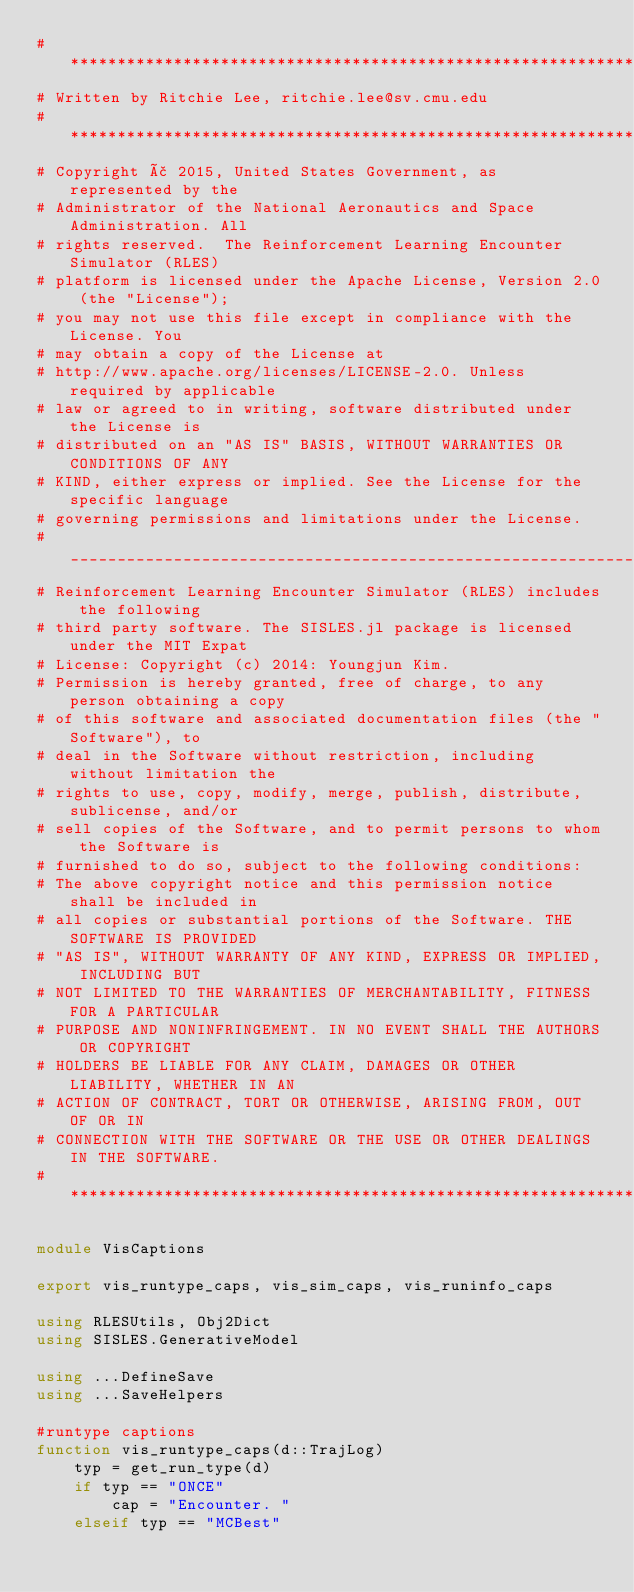Convert code to text. <code><loc_0><loc_0><loc_500><loc_500><_Julia_># *****************************************************************************
# Written by Ritchie Lee, ritchie.lee@sv.cmu.edu
# *****************************************************************************
# Copyright ã 2015, United States Government, as represented by the
# Administrator of the National Aeronautics and Space Administration. All
# rights reserved.  The Reinforcement Learning Encounter Simulator (RLES)
# platform is licensed under the Apache License, Version 2.0 (the "License");
# you may not use this file except in compliance with the License. You
# may obtain a copy of the License at
# http://www.apache.org/licenses/LICENSE-2.0. Unless required by applicable
# law or agreed to in writing, software distributed under the License is
# distributed on an "AS IS" BASIS, WITHOUT WARRANTIES OR CONDITIONS OF ANY
# KIND, either express or implied. See the License for the specific language
# governing permissions and limitations under the License.
# _____________________________________________________________________________
# Reinforcement Learning Encounter Simulator (RLES) includes the following
# third party software. The SISLES.jl package is licensed under the MIT Expat
# License: Copyright (c) 2014: Youngjun Kim.
# Permission is hereby granted, free of charge, to any person obtaining a copy
# of this software and associated documentation files (the "Software"), to
# deal in the Software without restriction, including without limitation the
# rights to use, copy, modify, merge, publish, distribute, sublicense, and/or
# sell copies of the Software, and to permit persons to whom the Software is
# furnished to do so, subject to the following conditions:
# The above copyright notice and this permission notice shall be included in
# all copies or substantial portions of the Software. THE SOFTWARE IS PROVIDED
# "AS IS", WITHOUT WARRANTY OF ANY KIND, EXPRESS OR IMPLIED, INCLUDING BUT
# NOT LIMITED TO THE WARRANTIES OF MERCHANTABILITY, FITNESS FOR A PARTICULAR
# PURPOSE AND NONINFRINGEMENT. IN NO EVENT SHALL THE AUTHORS OR COPYRIGHT
# HOLDERS BE LIABLE FOR ANY CLAIM, DAMAGES OR OTHER LIABILITY, WHETHER IN AN
# ACTION OF CONTRACT, TORT OR OTHERWISE, ARISING FROM, OUT OF OR IN
# CONNECTION WITH THE SOFTWARE OR THE USE OR OTHER DEALINGS IN THE SOFTWARE.
# *****************************************************************************

module VisCaptions

export vis_runtype_caps, vis_sim_caps, vis_runinfo_caps

using RLESUtils, Obj2Dict
using SISLES.GenerativeModel

using ...DefineSave
using ...SaveHelpers

#runtype captions
function vis_runtype_caps(d::TrajLog)
    typ = get_run_type(d)
    if typ == "ONCE"
        cap = "Encounter. "
    elseif typ == "MCBest"</code> 